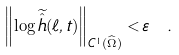<formula> <loc_0><loc_0><loc_500><loc_500>\left \| \log \widetilde { \hat { h } } ( \ell , t ) \right \| _ { C ^ { 1 } ( \widehat { \Omega } ) } < \varepsilon \ .</formula> 